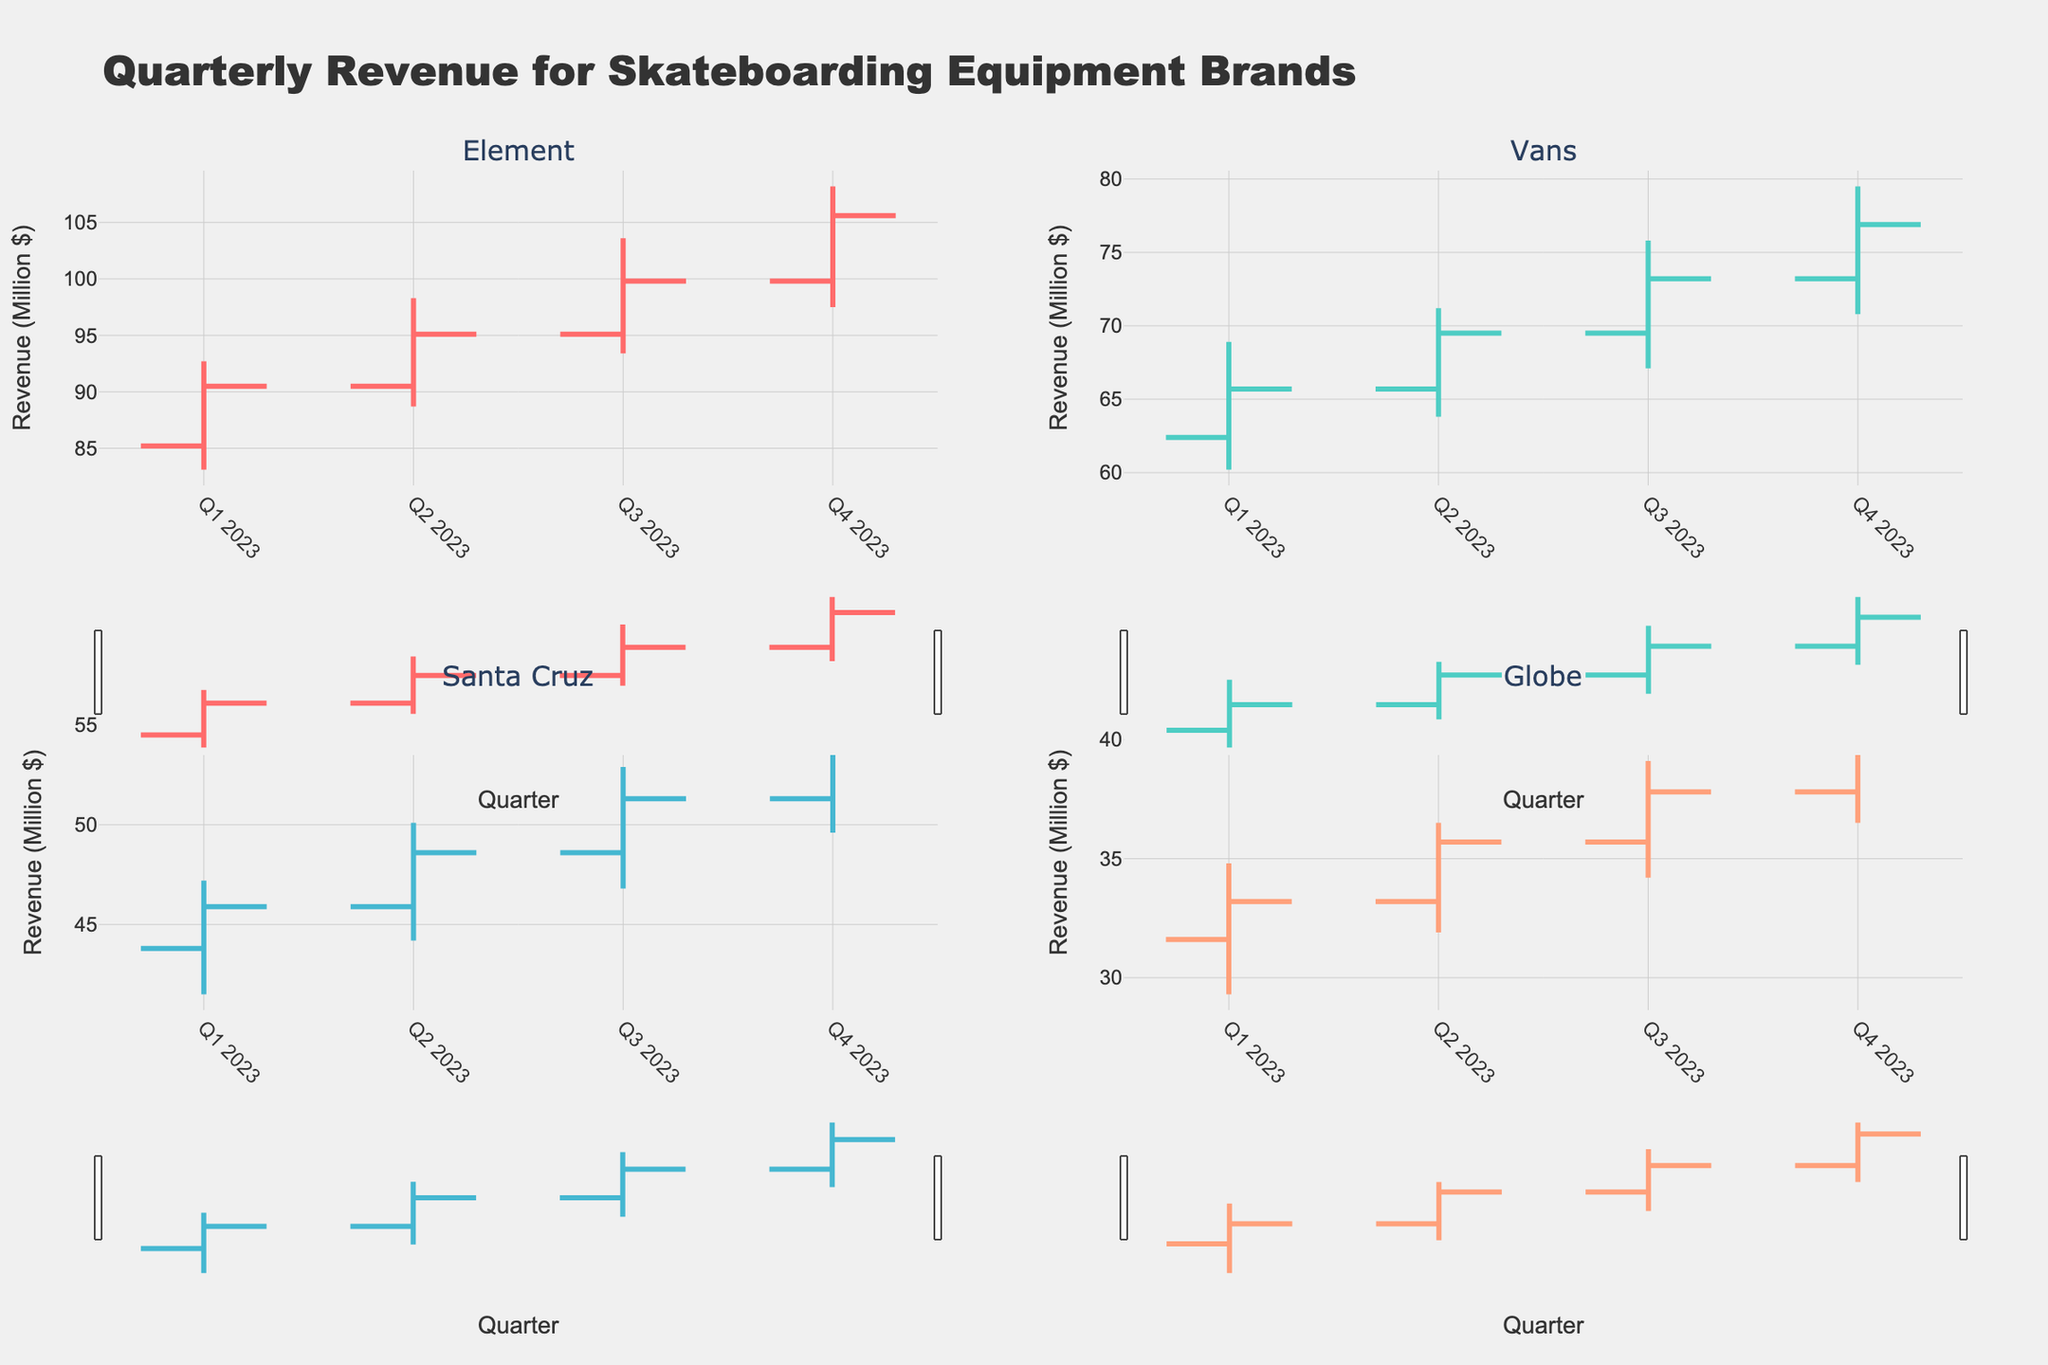Which company had the highest revenue in Q4 2023? Look at the figure for Q4 2023's closing values across all companies. The highest closing value belongs to Element, at 105.6 million dollars.
Answer: Element What was the opening revenue for Vans in Q2 2023? Find the opening value for Vans in Q2 2023, which is located at the starting point of the OHLC bar for the respective quarter and company. The value is 65.7 million dollars.
Answer: 65.7 million dollars Between Q1 2023 and Q2 2023, which company showed the highest increase in closing revenue? Calculate the difference in closing revenue between Q1 2023 and Q2 2023 for each company. Element's increase is 95.1 - 90.5 = 4.6, Vans' increase is 69.5 - 65.7 = 3.8, Santa Cruz's increase is 48.6 - 45.9 = 2.7, and Globe's increase is 35.7 - 33.2 = 2.5. Element shows the highest increase.
Answer: Element How many data points are there for each company? Each company has a data point for each quarter of 2023, making a total of 4 data points per company.
Answer: 4 What is the average high value for Globe across all quarters in 2023? Sum all the high values for Globe: 34.8 (Q1) + 36.5 (Q2) + 39.1 (Q3) + 41.2 (Q4) = 151.6, and divide by the number of quarters, 4. The average high value is 151.6 / 4 = 37.9 million dollars.
Answer: 37.9 million dollars Which quarter had the lowest opening value for Santa Cruz? Compare the opening values for Santa Cruz across all four quarters. The lowest opening value is in Q1 2023, at 43.8 million dollars.
Answer: Q1 2023 During which quarter did Element have the largest difference between its high and low values? Calculate the difference between the high and low values for Element in each quarter: Q1 (9.6), Q2 (9.6), Q3 (10.2), Q4 (10.7). The largest difference is in Q4 2023 at 10.7.
Answer: Q4 2023 Which company's closing revenue in Q3 2023 is closest to 100 million dollars? Look at the closing values in Q3 2023. Element is at 99.8 million dollars, which is closest to 100 million dollars.
Answer: Element 